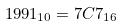Convert formula to latex. <formula><loc_0><loc_0><loc_500><loc_500>1 9 9 1 _ { 1 0 } = 7 C 7 _ { 1 6 }</formula> 